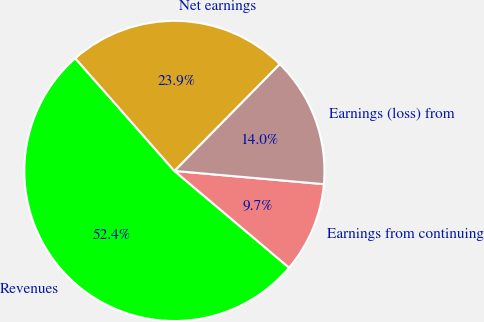<chart> <loc_0><loc_0><loc_500><loc_500><pie_chart><fcel>Revenues<fcel>Earnings from continuing<fcel>Earnings (loss) from<fcel>Net earnings<nl><fcel>52.36%<fcel>9.75%<fcel>14.02%<fcel>23.87%<nl></chart> 